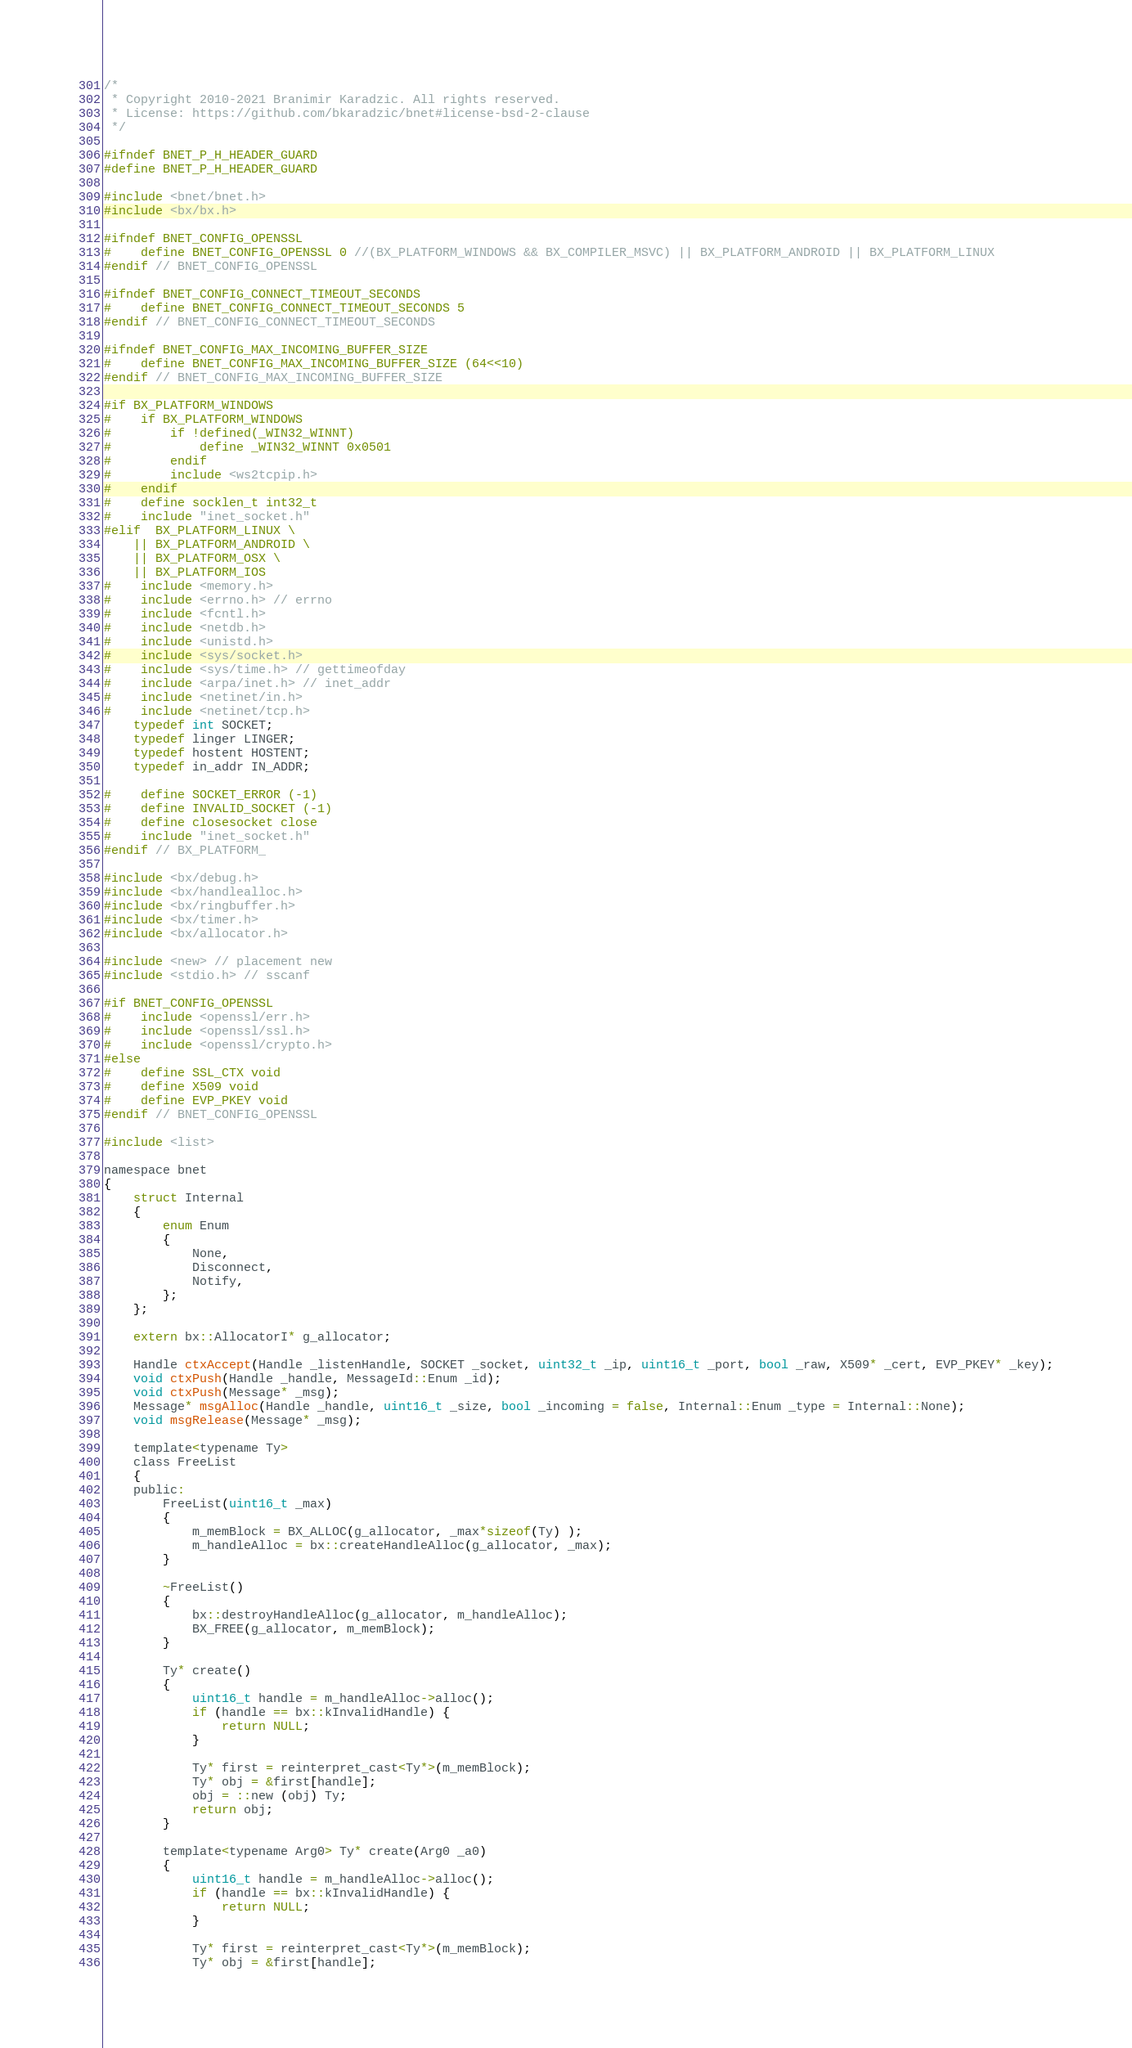Convert code to text. <code><loc_0><loc_0><loc_500><loc_500><_C_>/*
 * Copyright 2010-2021 Branimir Karadzic. All rights reserved.
 * License: https://github.com/bkaradzic/bnet#license-bsd-2-clause
 */

#ifndef BNET_P_H_HEADER_GUARD
#define BNET_P_H_HEADER_GUARD

#include <bnet/bnet.h>
#include <bx/bx.h>

#ifndef BNET_CONFIG_OPENSSL
#	define BNET_CONFIG_OPENSSL 0 //(BX_PLATFORM_WINDOWS && BX_COMPILER_MSVC) || BX_PLATFORM_ANDROID || BX_PLATFORM_LINUX
#endif // BNET_CONFIG_OPENSSL

#ifndef BNET_CONFIG_CONNECT_TIMEOUT_SECONDS
#	define BNET_CONFIG_CONNECT_TIMEOUT_SECONDS 5
#endif // BNET_CONFIG_CONNECT_TIMEOUT_SECONDS

#ifndef BNET_CONFIG_MAX_INCOMING_BUFFER_SIZE
#	define BNET_CONFIG_MAX_INCOMING_BUFFER_SIZE (64<<10)
#endif // BNET_CONFIG_MAX_INCOMING_BUFFER_SIZE

#if BX_PLATFORM_WINDOWS
#	if BX_PLATFORM_WINDOWS
#		if !defined(_WIN32_WINNT)
#			define _WIN32_WINNT 0x0501
#		endif
#		include <ws2tcpip.h>
#	endif
#	define socklen_t int32_t
#	include "inet_socket.h"
#elif  BX_PLATFORM_LINUX \
	|| BX_PLATFORM_ANDROID \
	|| BX_PLATFORM_OSX \
	|| BX_PLATFORM_IOS
#	include <memory.h>
#	include <errno.h> // errno
#	include <fcntl.h>
#	include <netdb.h>
#	include <unistd.h>
#	include <sys/socket.h>
#	include <sys/time.h> // gettimeofday
#	include <arpa/inet.h> // inet_addr
#	include <netinet/in.h>
#	include <netinet/tcp.h>
	typedef int SOCKET;
	typedef linger LINGER;
	typedef hostent HOSTENT;
	typedef in_addr IN_ADDR;

#	define SOCKET_ERROR (-1)
#	define INVALID_SOCKET (-1)
#	define closesocket close
#	include "inet_socket.h"
#endif // BX_PLATFORM_

#include <bx/debug.h>
#include <bx/handlealloc.h>
#include <bx/ringbuffer.h>
#include <bx/timer.h>
#include <bx/allocator.h>

#include <new> // placement new
#include <stdio.h> // sscanf

#if BNET_CONFIG_OPENSSL
#	include <openssl/err.h>
#	include <openssl/ssl.h>
#	include <openssl/crypto.h>
#else
#	define SSL_CTX void
#	define X509 void
#	define EVP_PKEY void
#endif // BNET_CONFIG_OPENSSL

#include <list>

namespace bnet
{
	struct Internal
	{
		enum Enum
		{
			None,
			Disconnect,
			Notify,
		};
	};

	extern bx::AllocatorI* g_allocator;

	Handle ctxAccept(Handle _listenHandle, SOCKET _socket, uint32_t _ip, uint16_t _port, bool _raw, X509* _cert, EVP_PKEY* _key);
	void ctxPush(Handle _handle, MessageId::Enum _id);
	void ctxPush(Message* _msg);
	Message* msgAlloc(Handle _handle, uint16_t _size, bool _incoming = false, Internal::Enum _type = Internal::None);
	void msgRelease(Message* _msg);

	template<typename Ty>
	class FreeList
	{
	public:
		FreeList(uint16_t _max)
		{
			m_memBlock = BX_ALLOC(g_allocator, _max*sizeof(Ty) );
			m_handleAlloc = bx::createHandleAlloc(g_allocator, _max);
		}

		~FreeList()
		{
			bx::destroyHandleAlloc(g_allocator, m_handleAlloc);
			BX_FREE(g_allocator, m_memBlock);
		}

		Ty* create()
		{
			uint16_t handle = m_handleAlloc->alloc();
			if (handle == bx::kInvalidHandle) {
				return NULL;
			}

			Ty* first = reinterpret_cast<Ty*>(m_memBlock);
			Ty* obj = &first[handle];
			obj = ::new (obj) Ty;
			return obj;
		}

		template<typename Arg0> Ty* create(Arg0 _a0)
		{
			uint16_t handle = m_handleAlloc->alloc();
			if (handle == bx::kInvalidHandle) {
				return NULL;
			}

			Ty* first = reinterpret_cast<Ty*>(m_memBlock);
			Ty* obj = &first[handle];</code> 